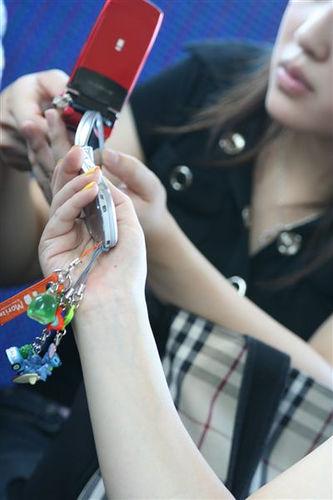What is the woman holding?
Write a very short answer. Cell phone. What style phone is it?
Give a very brief answer. Flip. What kind of phone is this?
Answer briefly. Flip. What color is the phone?
Write a very short answer. Red. 